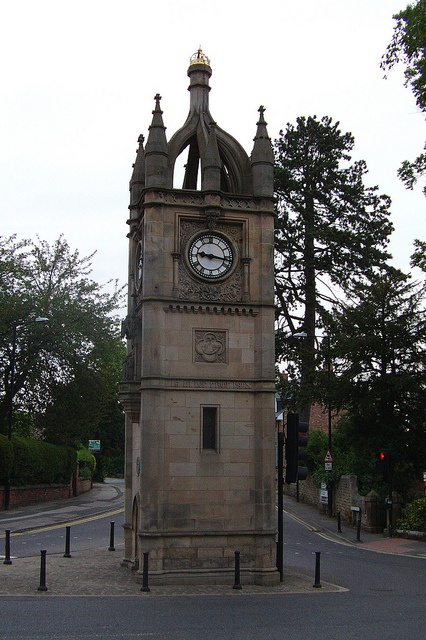Describe the objects in this image and their specific colors. I can see clock in white, black, gray, and darkgray tones, traffic light in white, black, and gray tones, clock in white, black, gray, and darkgray tones, and traffic light in white, black, brown, red, and maroon tones in this image. 